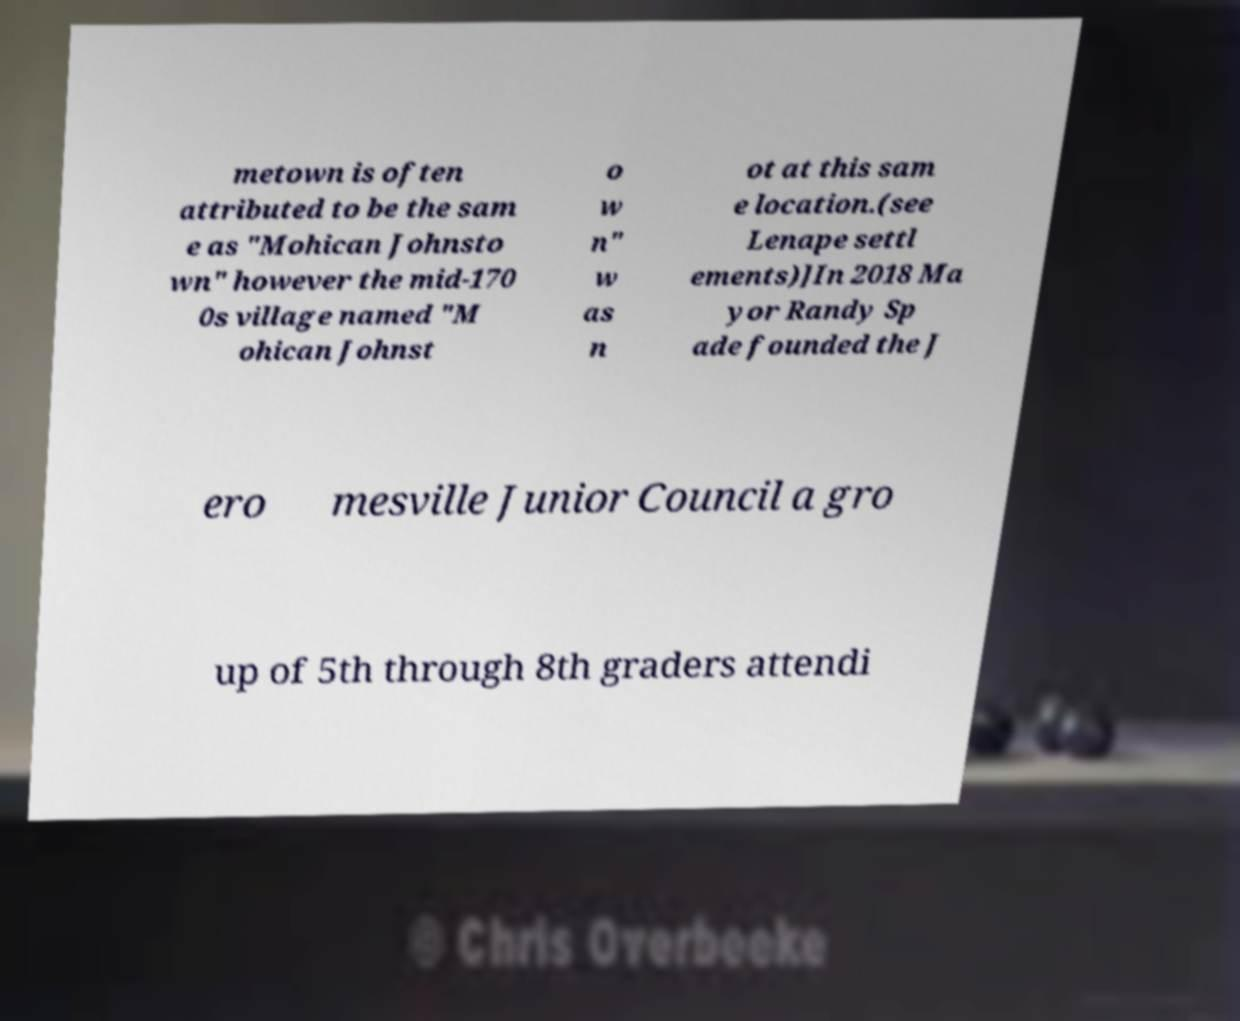What messages or text are displayed in this image? I need them in a readable, typed format. metown is often attributed to be the sam e as "Mohican Johnsto wn" however the mid-170 0s village named "M ohican Johnst o w n" w as n ot at this sam e location.(see Lenape settl ements)]In 2018 Ma yor Randy Sp ade founded the J ero mesville Junior Council a gro up of 5th through 8th graders attendi 